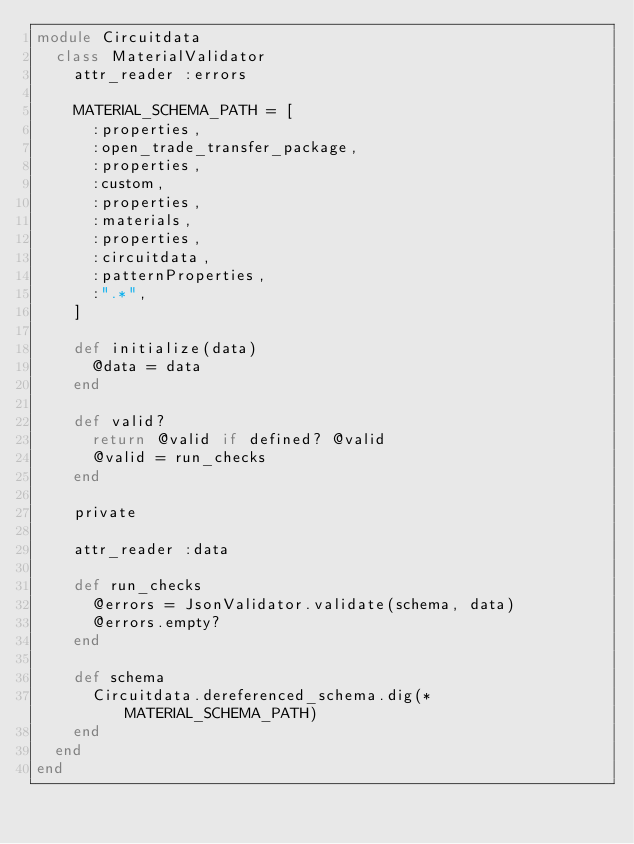Convert code to text. <code><loc_0><loc_0><loc_500><loc_500><_Ruby_>module Circuitdata
  class MaterialValidator
    attr_reader :errors

    MATERIAL_SCHEMA_PATH = [
      :properties,
      :open_trade_transfer_package,
      :properties,
      :custom,
      :properties,
      :materials,
      :properties,
      :circuitdata,
      :patternProperties,
      :".*",
    ]

    def initialize(data)
      @data = data
    end

    def valid?
      return @valid if defined? @valid
      @valid = run_checks
    end

    private

    attr_reader :data

    def run_checks
      @errors = JsonValidator.validate(schema, data)
      @errors.empty?
    end

    def schema
      Circuitdata.dereferenced_schema.dig(*MATERIAL_SCHEMA_PATH)
    end
  end
end
</code> 